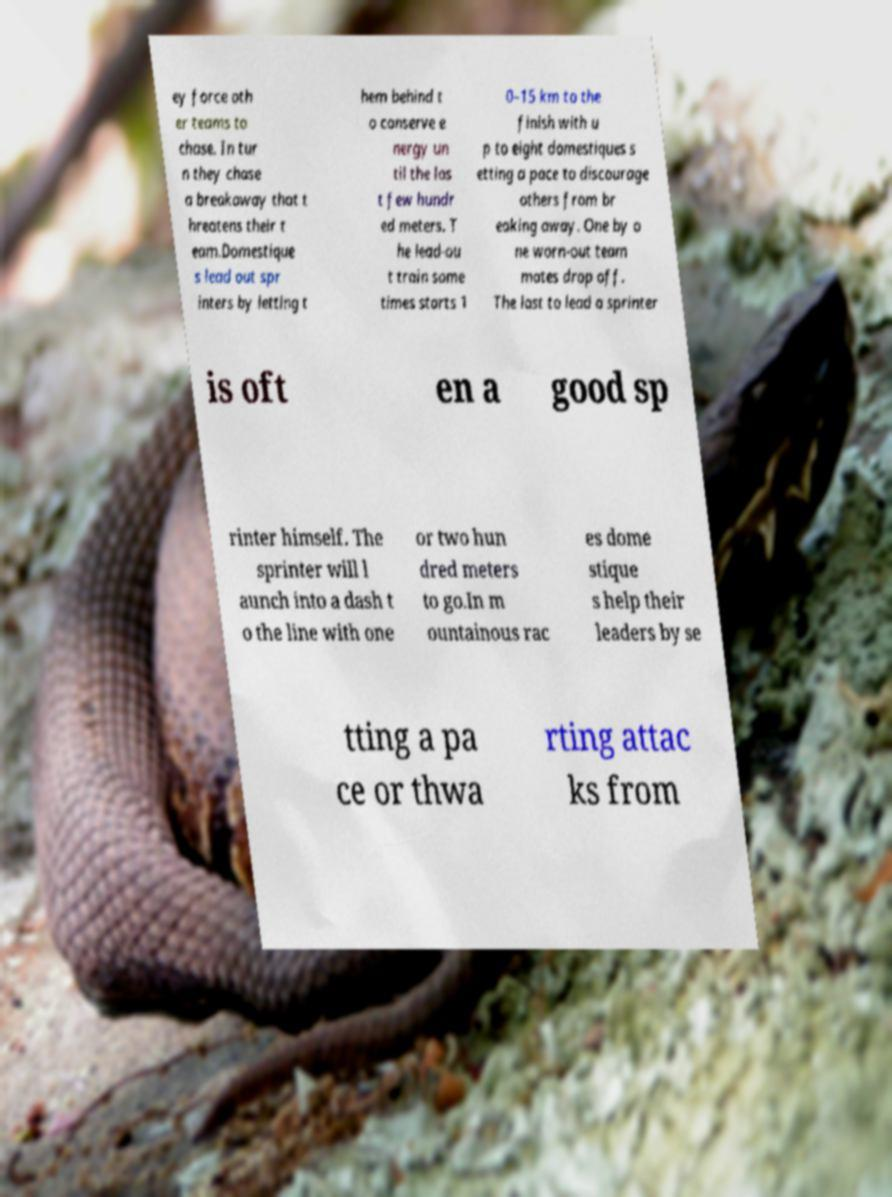There's text embedded in this image that I need extracted. Can you transcribe it verbatim? ey force oth er teams to chase. In tur n they chase a breakaway that t hreatens their t eam.Domestique s lead out spr inters by letting t hem behind t o conserve e nergy un til the las t few hundr ed meters. T he lead-ou t train some times starts 1 0–15 km to the finish with u p to eight domestiques s etting a pace to discourage others from br eaking away. One by o ne worn-out team mates drop off. The last to lead a sprinter is oft en a good sp rinter himself. The sprinter will l aunch into a dash t o the line with one or two hun dred meters to go.In m ountainous rac es dome stique s help their leaders by se tting a pa ce or thwa rting attac ks from 